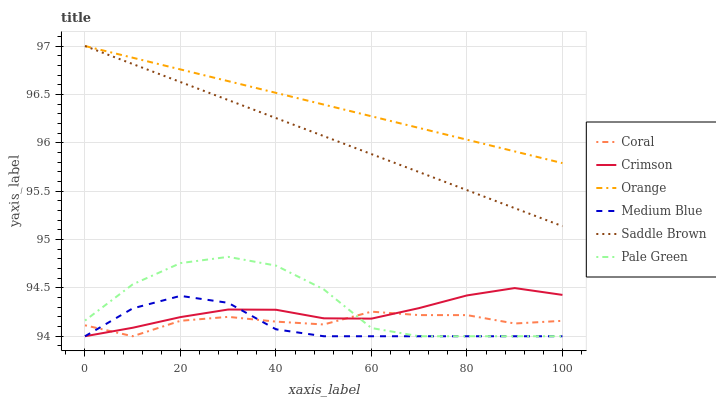Does Medium Blue have the minimum area under the curve?
Answer yes or no. Yes. Does Orange have the maximum area under the curve?
Answer yes or no. Yes. Does Orange have the minimum area under the curve?
Answer yes or no. No. Does Medium Blue have the maximum area under the curve?
Answer yes or no. No. Is Saddle Brown the smoothest?
Answer yes or no. Yes. Is Pale Green the roughest?
Answer yes or no. Yes. Is Medium Blue the smoothest?
Answer yes or no. No. Is Medium Blue the roughest?
Answer yes or no. No. Does Coral have the lowest value?
Answer yes or no. Yes. Does Orange have the lowest value?
Answer yes or no. No. Does Saddle Brown have the highest value?
Answer yes or no. Yes. Does Medium Blue have the highest value?
Answer yes or no. No. Is Medium Blue less than Saddle Brown?
Answer yes or no. Yes. Is Saddle Brown greater than Pale Green?
Answer yes or no. Yes. Does Orange intersect Saddle Brown?
Answer yes or no. Yes. Is Orange less than Saddle Brown?
Answer yes or no. No. Is Orange greater than Saddle Brown?
Answer yes or no. No. Does Medium Blue intersect Saddle Brown?
Answer yes or no. No. 